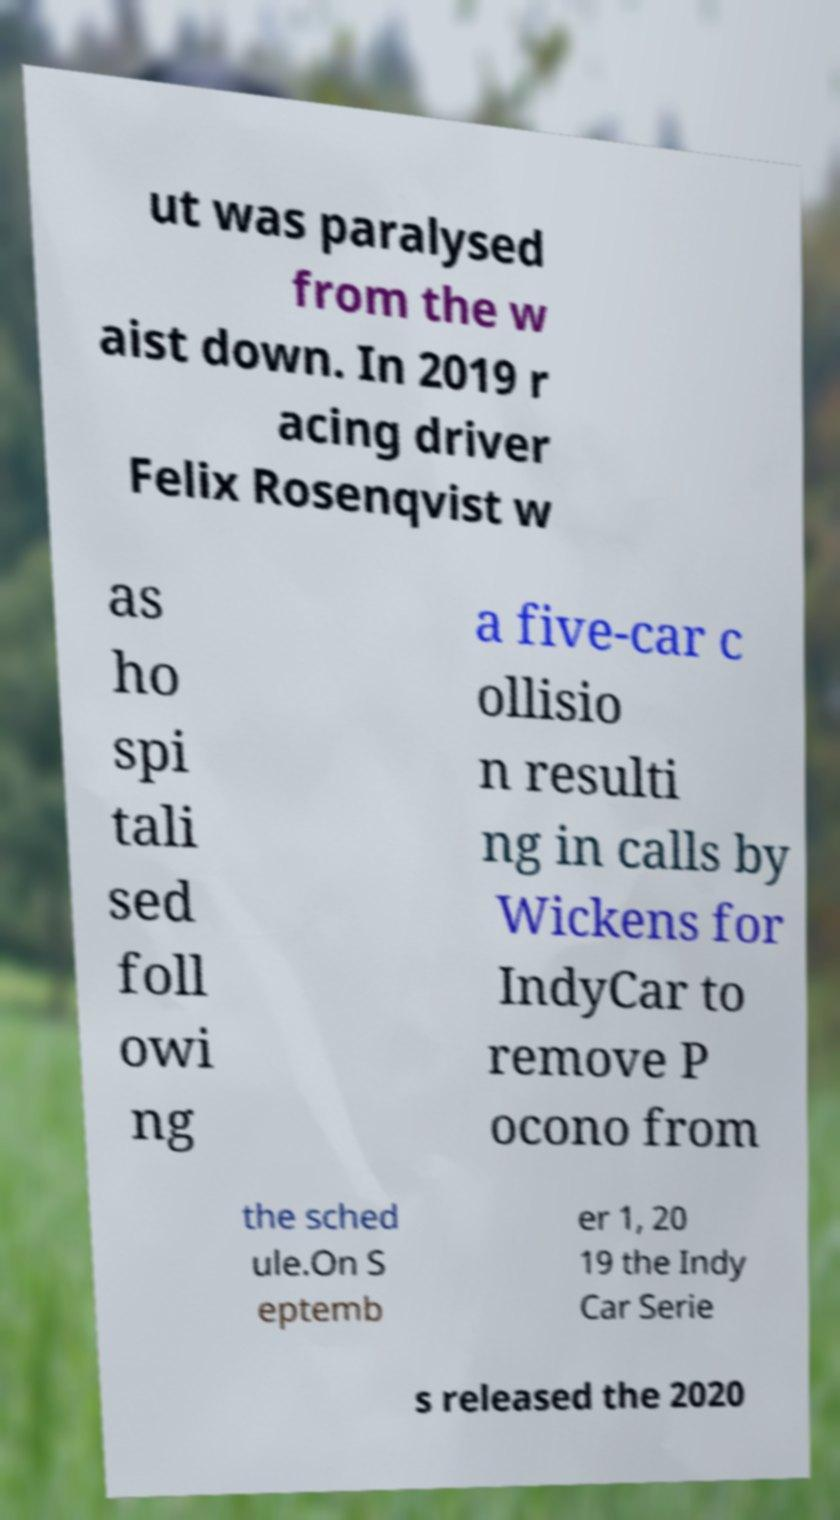There's text embedded in this image that I need extracted. Can you transcribe it verbatim? ut was paralysed from the w aist down. In 2019 r acing driver Felix Rosenqvist w as ho spi tali sed foll owi ng a five-car c ollisio n resulti ng in calls by Wickens for IndyCar to remove P ocono from the sched ule.On S eptemb er 1, 20 19 the Indy Car Serie s released the 2020 